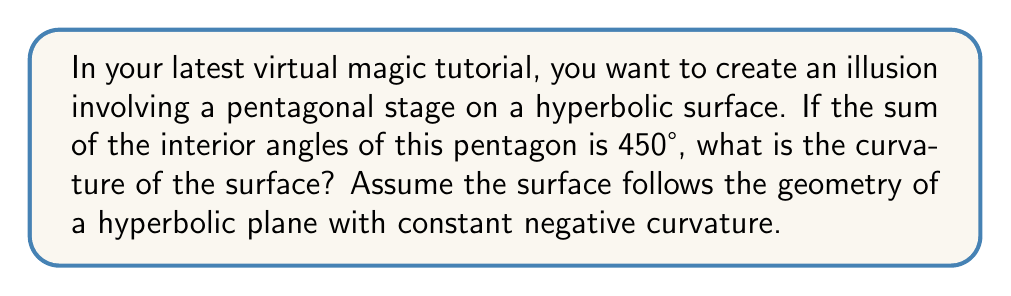Show me your answer to this math problem. Let's approach this step-by-step:

1) In Euclidean geometry, the sum of interior angles of a pentagon is $(5-2) \times 180° = 540°$. However, we're given that the sum is 450°, which indicates we're dealing with a hyperbolic surface.

2) For a polygon with $n$ sides on a surface with Gaussian curvature $K$, the sum of interior angles $S$ is given by the formula:

   $$S = (n-2)\pi + KA$$

   Where $A$ is the area of the polygon.

3) Converting our given sum to radians:
   
   $$450° \times \frac{\pi}{180°} = \frac{5\pi}{2}$$

4) Substituting into our formula:

   $$\frac{5\pi}{2} = (5-2)\pi + KA$$
   $$\frac{5\pi}{2} = 3\pi + KA$$

5) Subtracting $3\pi$ from both sides:

   $$\frac{5\pi}{2} - 3\pi = KA$$
   $$-\frac{\pi}{2} = KA$$

6) Dividing both sides by $A$:

   $$K = -\frac{\pi}{2A}$$

7) This confirms that $K$ is negative (as expected for a hyperbolic surface) and inversely proportional to the area of the pentagon.

8) The exact value of $K$ depends on the area $A$, which we don't know. However, we can express the curvature in terms of the area.
Answer: $K = -\frac{\pi}{2A}$ 